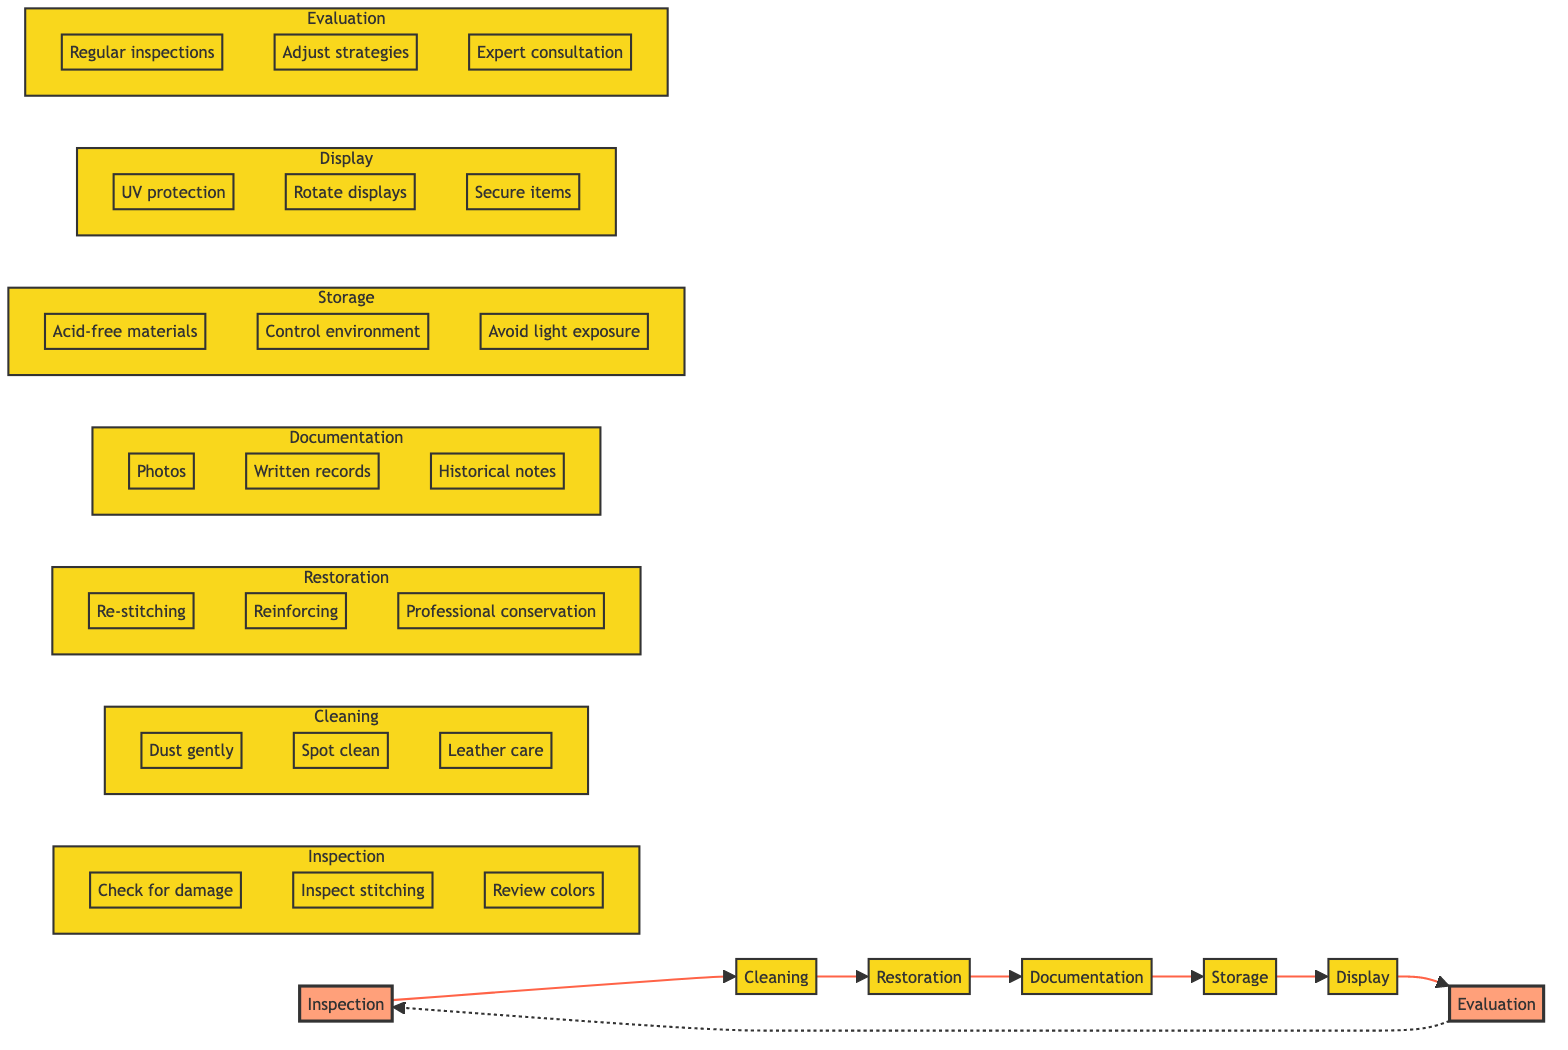What is the first step in the maintenance routine? The first step in the maintenance routine is "Inspection," which is indicated as the starting point in the diagram's flow.
Answer: Inspection How many main steps are there in the maintenance routine? There are seven main steps illustrated in the flowchart: Inspection, Cleaning, Restoration, Documentation, Storage, Display, and Evaluation.
Answer: Seven What follows after Cleaning in the diagram? After the Cleaning step, the next step in the flowchart is Restoration, indicated by the arrow leading from Cleaning to Restoration.
Answer: Restoration What is the last step before returning to Inspection? The last step before returning to Inspection is Evaluation, as shown in the flowchart that loops back to Inspection after Evaluation.
Answer: Evaluation What kind of protection is recommended for display? The recommendation for display protection includes using UV-protective glass, as stated in the Display section of the flowchart.
Answer: UV protection Name one action suggested under the Documentation step. One action suggested under Documentation is to keep "Photos," which is specified as part of the details in that section of the flowchart.
Answer: Photos What type of materials should be used for Storage? The flowchart indicates that "Acid-free materials" should be used for Storage, as noted in the respective section.
Answer: Acid-free materials How does the cleaning of leather items differ from other materials? The flowchart specifies "Specialized cleaning for leather items" in the Cleaning section, highlighting a distinct approach compared to cleaning other fabrics.
Answer: Specialized cleaning What is a key action to take during the Evaluation phase? A key action in the Evaluation phase is to schedule "Regular inspections," which is listed as an important part of that step in the flowchart.
Answer: Regular inspections 